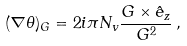Convert formula to latex. <formula><loc_0><loc_0><loc_500><loc_500>( { \nabla } \theta ) _ { G } = 2 i \pi N _ { v } \frac { { G } \times \hat { e } _ { z } } { G ^ { 2 } } \, ,</formula> 